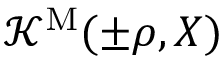<formula> <loc_0><loc_0><loc_500><loc_500>{ \mathcal { K } } ^ { M } ( \pm \rho , X )</formula> 